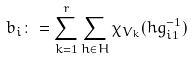<formula> <loc_0><loc_0><loc_500><loc_500>b _ { i } \colon = \sum _ { k = 1 } ^ { r } \sum _ { h \in H } \chi _ { V _ { k } } ( h g _ { i 1 } ^ { - 1 } )</formula> 